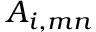<formula> <loc_0><loc_0><loc_500><loc_500>A _ { i , m n }</formula> 